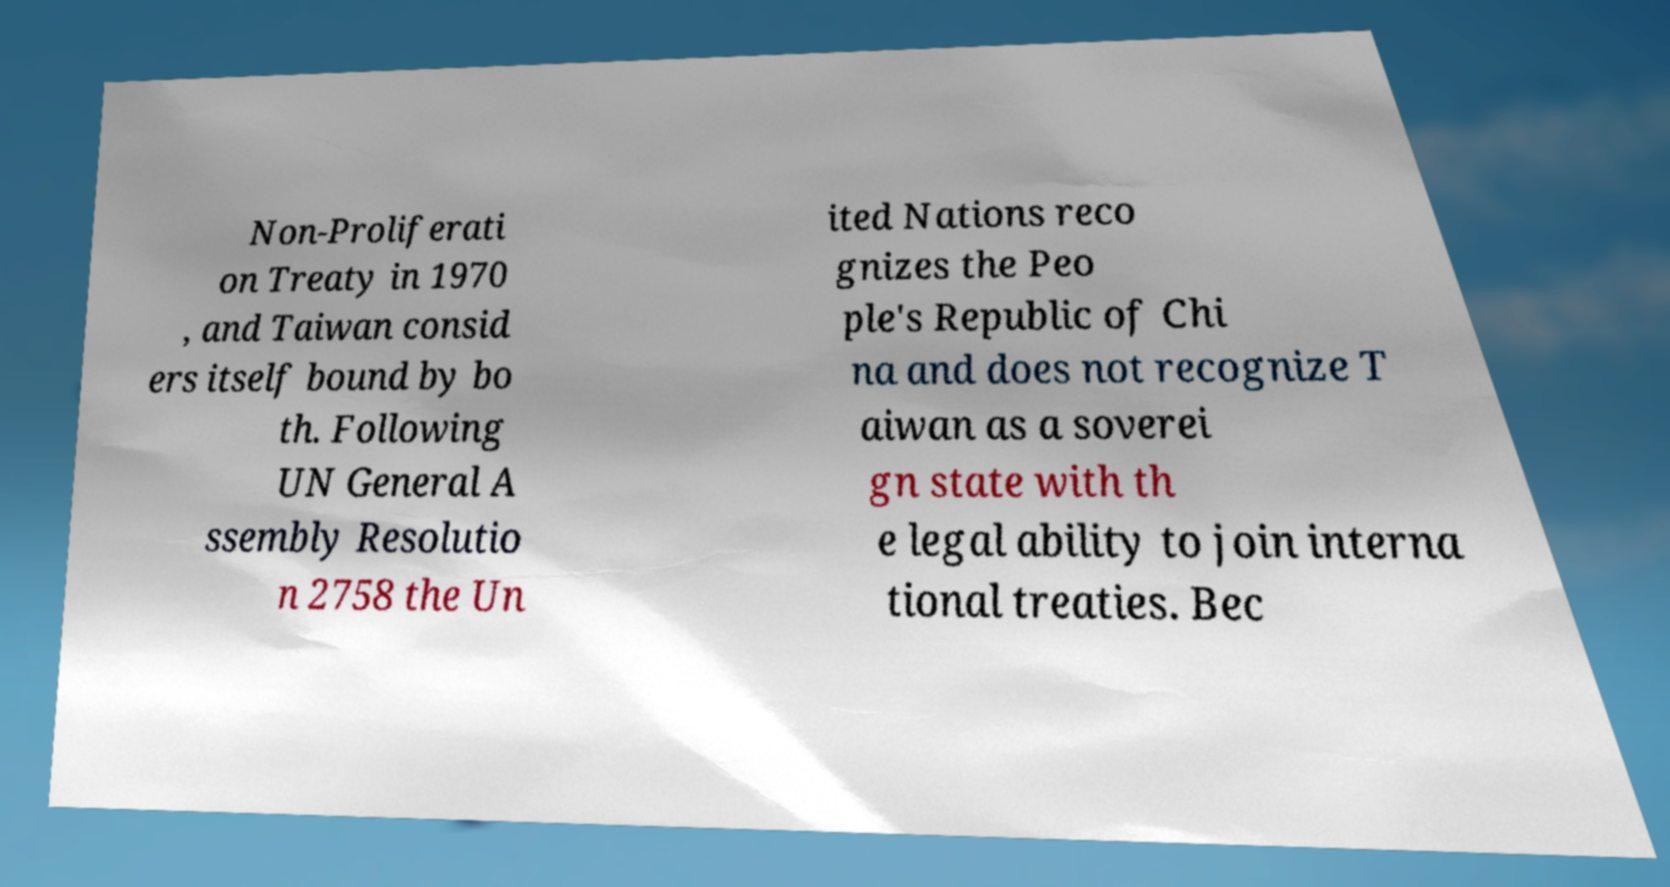Please read and relay the text visible in this image. What does it say? Non-Proliferati on Treaty in 1970 , and Taiwan consid ers itself bound by bo th. Following UN General A ssembly Resolutio n 2758 the Un ited Nations reco gnizes the Peo ple's Republic of Chi na and does not recognize T aiwan as a soverei gn state with th e legal ability to join interna tional treaties. Bec 